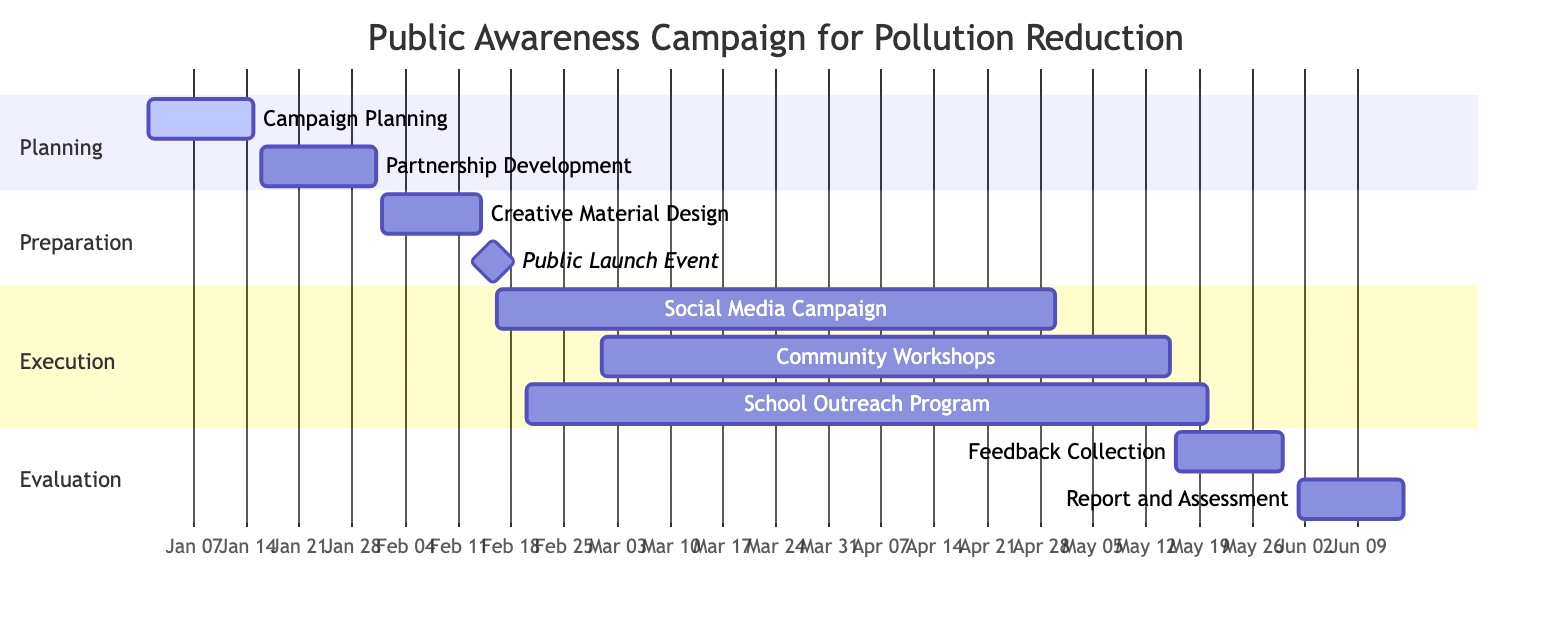What is the first task in the campaign? The first task is labeled "Campaign Planning" and is the topmost task in the Gantt chart's Planning section.
Answer: Campaign Planning How long does the "Social Media Campaign" last? The "Social Media Campaign" starts on February 16, 2024, and ends on April 30, 2024, which is a duration of about 2.5 months.
Answer: 2.5 months What is the last task shown in the diagram? The last task is "Report and Assessment," which is the final entry in the Evaluation section.
Answer: Report and Assessment In which section is the "Public Launch Event" located? The "Public Launch Event" is marked under the Preparation section of the Gantt chart.
Answer: Preparation Which task is scheduled to start just after "Community Workshops"? "Feedback Collection" is scheduled to start immediately after the "Community Workshops" end on May 15, 2024.
Answer: Feedback Collection How many tasks are planned in the Execution section? There are three tasks listed in the Execution section: "Social Media Campaign," "Community Workshops," and "School Outreach Program."
Answer: 3 Which task overlaps with both "Social Media Campaign" and "School Outreach Program"? The "Community Workshops" task overlaps with both the "Social Media Campaign" and "School Outreach Program," as it starts in March while both social media and school outreach tasks begin earlier in February.
Answer: Community Workshops What is the milestone date for the "Public Launch Event"? The milestone date for the "Public Launch Event" is February 15, 2024, as it's marked in the Gantt chart.
Answer: February 15, 2024 How many days does the "Campaign Planning" task take? The "Campaign Planning" task starts on January 1, 2024, and ends on January 15, 2024, thus taking a total of 15 days.
Answer: 15 days 